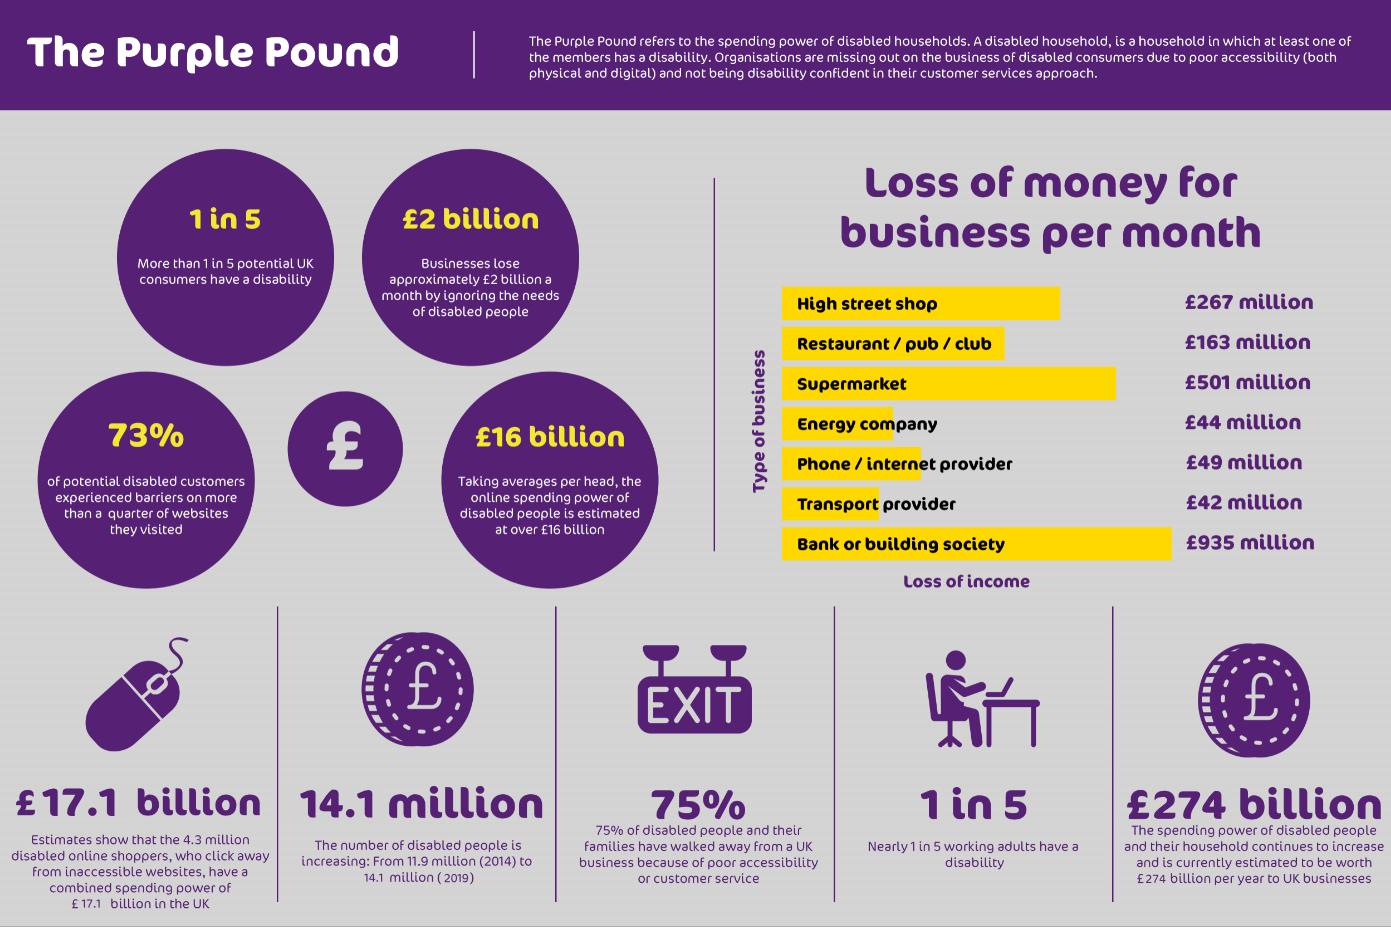Outline some significant characteristics in this image. The number of disabled people increased by approximately 2.2 million between 2014 and 2019. Among the seven types of businesses presented, the most disability-friendly is the transport provider. A non-disabled-friendly business, such as a bank or building society, is likely to incur the highest amount of loss due to not being accessible and accommodating to disabled individuals. It is estimated that seven types of businesses fail to consider the needs of disabled individuals and ignore their potential for loss of income. The loss of income for an energy company is significantly greater than that of a transport provider, to the tune of millions of pounds. 